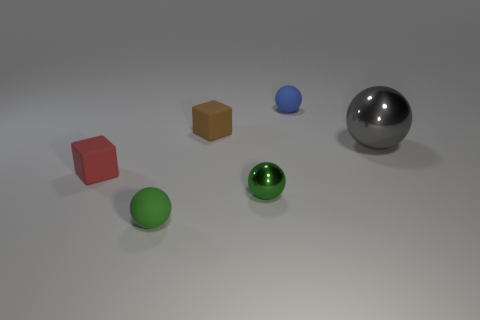Subtract all small blue spheres. How many spheres are left? 3 Subtract all red blocks. How many blocks are left? 1 Add 4 red things. How many objects exist? 10 Subtract all balls. How many objects are left? 2 Subtract 1 balls. How many balls are left? 3 Add 5 small blue spheres. How many small blue spheres are left? 6 Add 3 small green matte spheres. How many small green matte spheres exist? 4 Subtract 0 red cylinders. How many objects are left? 6 Subtract all yellow spheres. Subtract all gray cylinders. How many spheres are left? 4 Subtract all yellow cylinders. How many brown balls are left? 0 